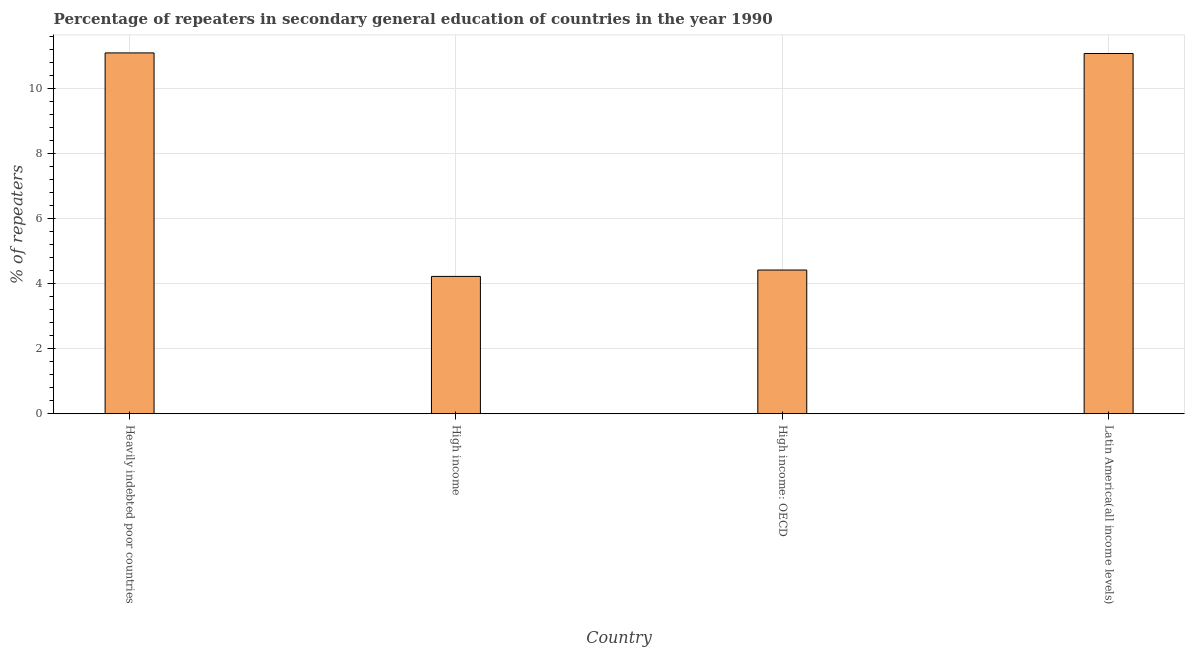Does the graph contain grids?
Provide a succinct answer. Yes. What is the title of the graph?
Ensure brevity in your answer.  Percentage of repeaters in secondary general education of countries in the year 1990. What is the label or title of the X-axis?
Your answer should be compact. Country. What is the label or title of the Y-axis?
Ensure brevity in your answer.  % of repeaters. What is the percentage of repeaters in High income: OECD?
Provide a short and direct response. 4.42. Across all countries, what is the maximum percentage of repeaters?
Give a very brief answer. 11.1. Across all countries, what is the minimum percentage of repeaters?
Give a very brief answer. 4.23. In which country was the percentage of repeaters maximum?
Make the answer very short. Heavily indebted poor countries. What is the sum of the percentage of repeaters?
Give a very brief answer. 30.84. What is the difference between the percentage of repeaters in High income and High income: OECD?
Your answer should be very brief. -0.2. What is the average percentage of repeaters per country?
Offer a very short reply. 7.71. What is the median percentage of repeaters?
Give a very brief answer. 7.75. In how many countries, is the percentage of repeaters greater than 2 %?
Offer a terse response. 4. Is the percentage of repeaters in Heavily indebted poor countries less than that in High income: OECD?
Keep it short and to the point. No. Is the difference between the percentage of repeaters in Heavily indebted poor countries and Latin America(all income levels) greater than the difference between any two countries?
Provide a short and direct response. No. What is the difference between the highest and the second highest percentage of repeaters?
Make the answer very short. 0.02. Is the sum of the percentage of repeaters in Heavily indebted poor countries and High income: OECD greater than the maximum percentage of repeaters across all countries?
Your response must be concise. Yes. What is the difference between the highest and the lowest percentage of repeaters?
Ensure brevity in your answer.  6.88. How many bars are there?
Your answer should be very brief. 4. Are all the bars in the graph horizontal?
Offer a very short reply. No. How many countries are there in the graph?
Your answer should be compact. 4. Are the values on the major ticks of Y-axis written in scientific E-notation?
Your answer should be very brief. No. What is the % of repeaters of Heavily indebted poor countries?
Ensure brevity in your answer.  11.1. What is the % of repeaters in High income?
Offer a very short reply. 4.23. What is the % of repeaters of High income: OECD?
Offer a terse response. 4.42. What is the % of repeaters in Latin America(all income levels)?
Keep it short and to the point. 11.09. What is the difference between the % of repeaters in Heavily indebted poor countries and High income?
Offer a terse response. 6.88. What is the difference between the % of repeaters in Heavily indebted poor countries and High income: OECD?
Provide a short and direct response. 6.68. What is the difference between the % of repeaters in Heavily indebted poor countries and Latin America(all income levels)?
Your answer should be compact. 0.02. What is the difference between the % of repeaters in High income and High income: OECD?
Your answer should be very brief. -0.2. What is the difference between the % of repeaters in High income and Latin America(all income levels)?
Your answer should be compact. -6.86. What is the difference between the % of repeaters in High income: OECD and Latin America(all income levels)?
Your answer should be very brief. -6.66. What is the ratio of the % of repeaters in Heavily indebted poor countries to that in High income?
Offer a very short reply. 2.63. What is the ratio of the % of repeaters in Heavily indebted poor countries to that in High income: OECD?
Your response must be concise. 2.51. What is the ratio of the % of repeaters in Heavily indebted poor countries to that in Latin America(all income levels)?
Keep it short and to the point. 1. What is the ratio of the % of repeaters in High income to that in High income: OECD?
Offer a very short reply. 0.96. What is the ratio of the % of repeaters in High income to that in Latin America(all income levels)?
Keep it short and to the point. 0.38. What is the ratio of the % of repeaters in High income: OECD to that in Latin America(all income levels)?
Offer a very short reply. 0.4. 